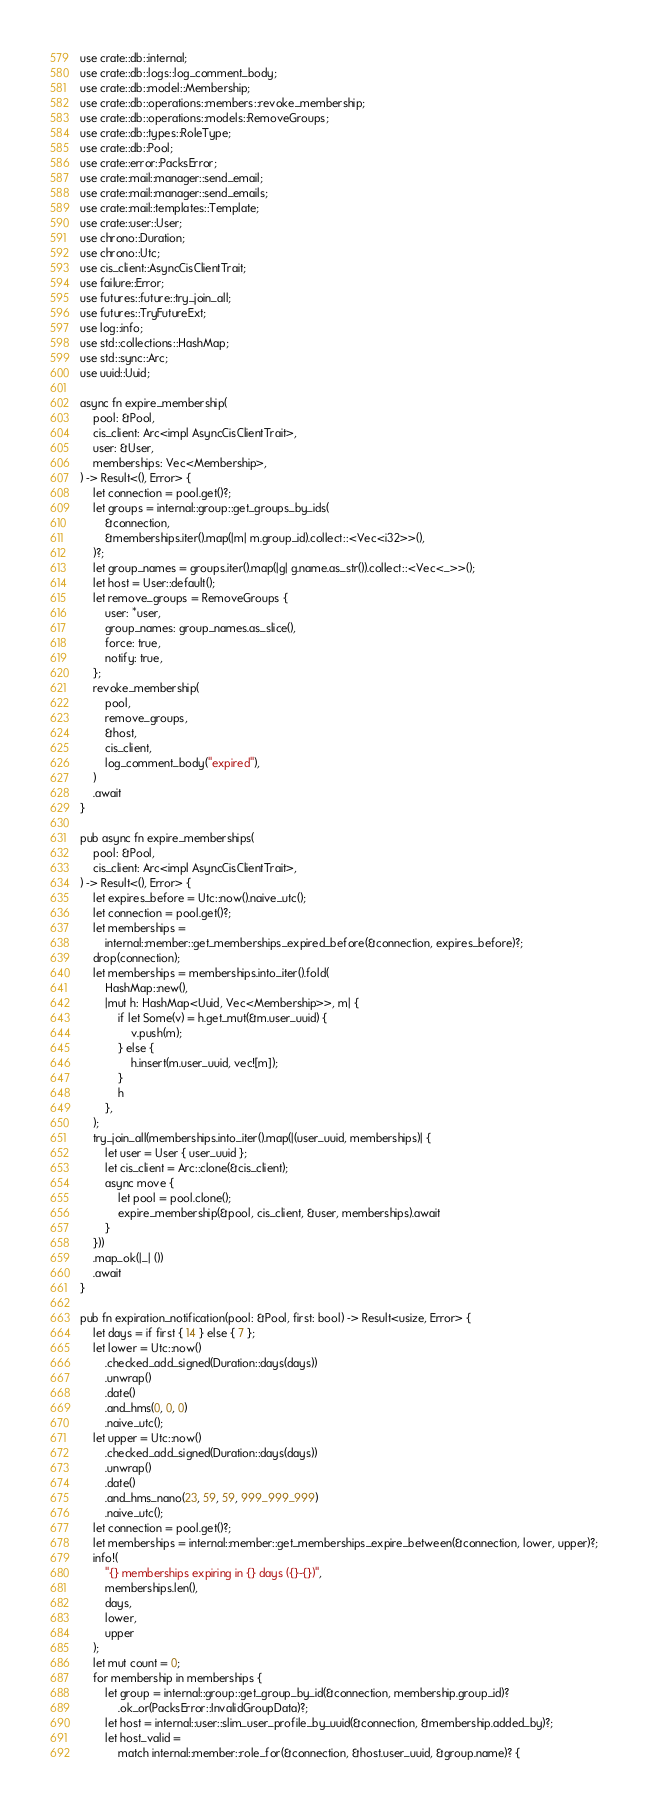Convert code to text. <code><loc_0><loc_0><loc_500><loc_500><_Rust_>use crate::db::internal;
use crate::db::logs::log_comment_body;
use crate::db::model::Membership;
use crate::db::operations::members::revoke_membership;
use crate::db::operations::models::RemoveGroups;
use crate::db::types::RoleType;
use crate::db::Pool;
use crate::error::PacksError;
use crate::mail::manager::send_email;
use crate::mail::manager::send_emails;
use crate::mail::templates::Template;
use crate::user::User;
use chrono::Duration;
use chrono::Utc;
use cis_client::AsyncCisClientTrait;
use failure::Error;
use futures::future::try_join_all;
use futures::TryFutureExt;
use log::info;
use std::collections::HashMap;
use std::sync::Arc;
use uuid::Uuid;

async fn expire_membership(
    pool: &Pool,
    cis_client: Arc<impl AsyncCisClientTrait>,
    user: &User,
    memberships: Vec<Membership>,
) -> Result<(), Error> {
    let connection = pool.get()?;
    let groups = internal::group::get_groups_by_ids(
        &connection,
        &memberships.iter().map(|m| m.group_id).collect::<Vec<i32>>(),
    )?;
    let group_names = groups.iter().map(|g| g.name.as_str()).collect::<Vec<_>>();
    let host = User::default();
    let remove_groups = RemoveGroups {
        user: *user,
        group_names: group_names.as_slice(),
        force: true,
        notify: true,
    };
    revoke_membership(
        pool,
        remove_groups,
        &host,
        cis_client,
        log_comment_body("expired"),
    )
    .await
}

pub async fn expire_memberships(
    pool: &Pool,
    cis_client: Arc<impl AsyncCisClientTrait>,
) -> Result<(), Error> {
    let expires_before = Utc::now().naive_utc();
    let connection = pool.get()?;
    let memberships =
        internal::member::get_memberships_expired_before(&connection, expires_before)?;
    drop(connection);
    let memberships = memberships.into_iter().fold(
        HashMap::new(),
        |mut h: HashMap<Uuid, Vec<Membership>>, m| {
            if let Some(v) = h.get_mut(&m.user_uuid) {
                v.push(m);
            } else {
                h.insert(m.user_uuid, vec![m]);
            }
            h
        },
    );
    try_join_all(memberships.into_iter().map(|(user_uuid, memberships)| {
        let user = User { user_uuid };
        let cis_client = Arc::clone(&cis_client);
        async move {
            let pool = pool.clone();
            expire_membership(&pool, cis_client, &user, memberships).await
        }
    }))
    .map_ok(|_| ())
    .await
}

pub fn expiration_notification(pool: &Pool, first: bool) -> Result<usize, Error> {
    let days = if first { 14 } else { 7 };
    let lower = Utc::now()
        .checked_add_signed(Duration::days(days))
        .unwrap()
        .date()
        .and_hms(0, 0, 0)
        .naive_utc();
    let upper = Utc::now()
        .checked_add_signed(Duration::days(days))
        .unwrap()
        .date()
        .and_hms_nano(23, 59, 59, 999_999_999)
        .naive_utc();
    let connection = pool.get()?;
    let memberships = internal::member::get_memberships_expire_between(&connection, lower, upper)?;
    info!(
        "{} memberships expiring in {} days ({}-{})",
        memberships.len(),
        days,
        lower,
        upper
    );
    let mut count = 0;
    for membership in memberships {
        let group = internal::group::get_group_by_id(&connection, membership.group_id)?
            .ok_or(PacksError::InvalidGroupData)?;
        let host = internal::user::slim_user_profile_by_uuid(&connection, &membership.added_by)?;
        let host_valid =
            match internal::member::role_for(&connection, &host.user_uuid, &group.name)? {</code> 